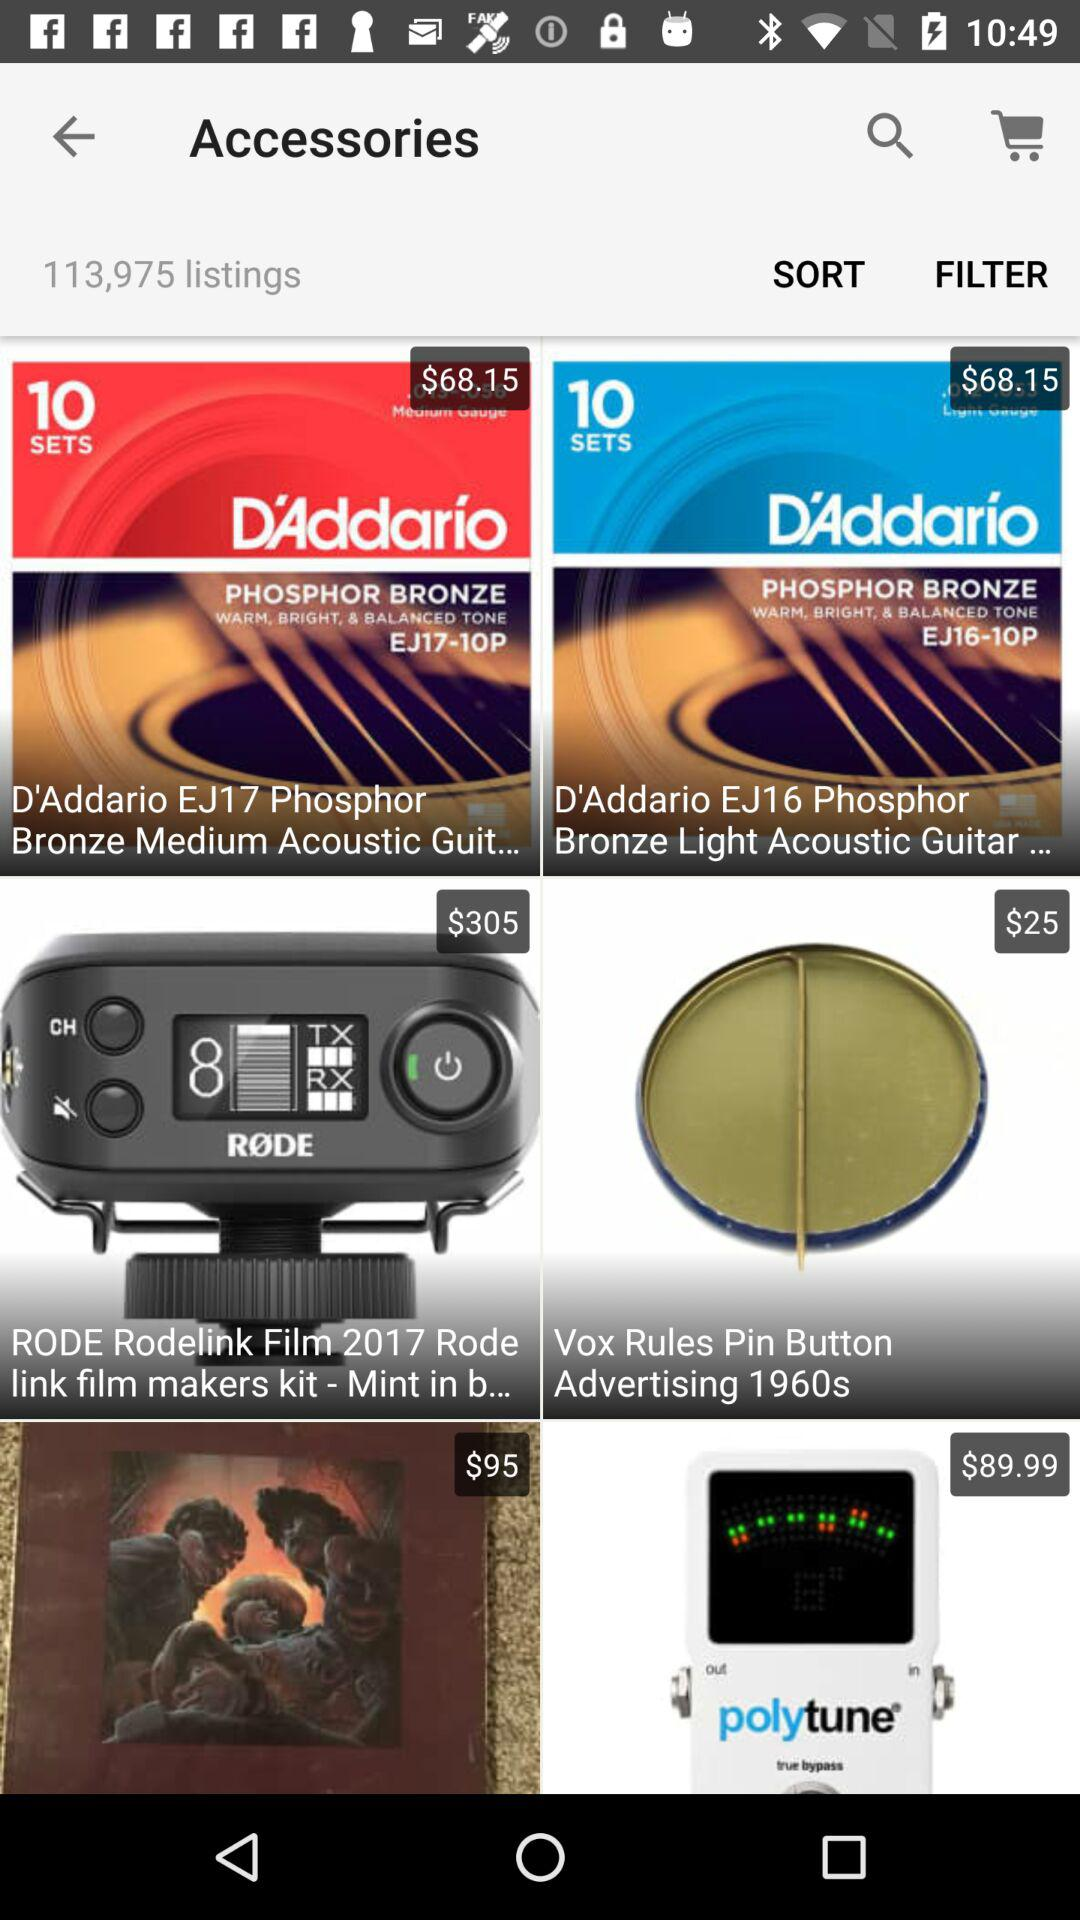How many sets are available in "D'Addario"? There are 10 sets are available in "D'Addario". 